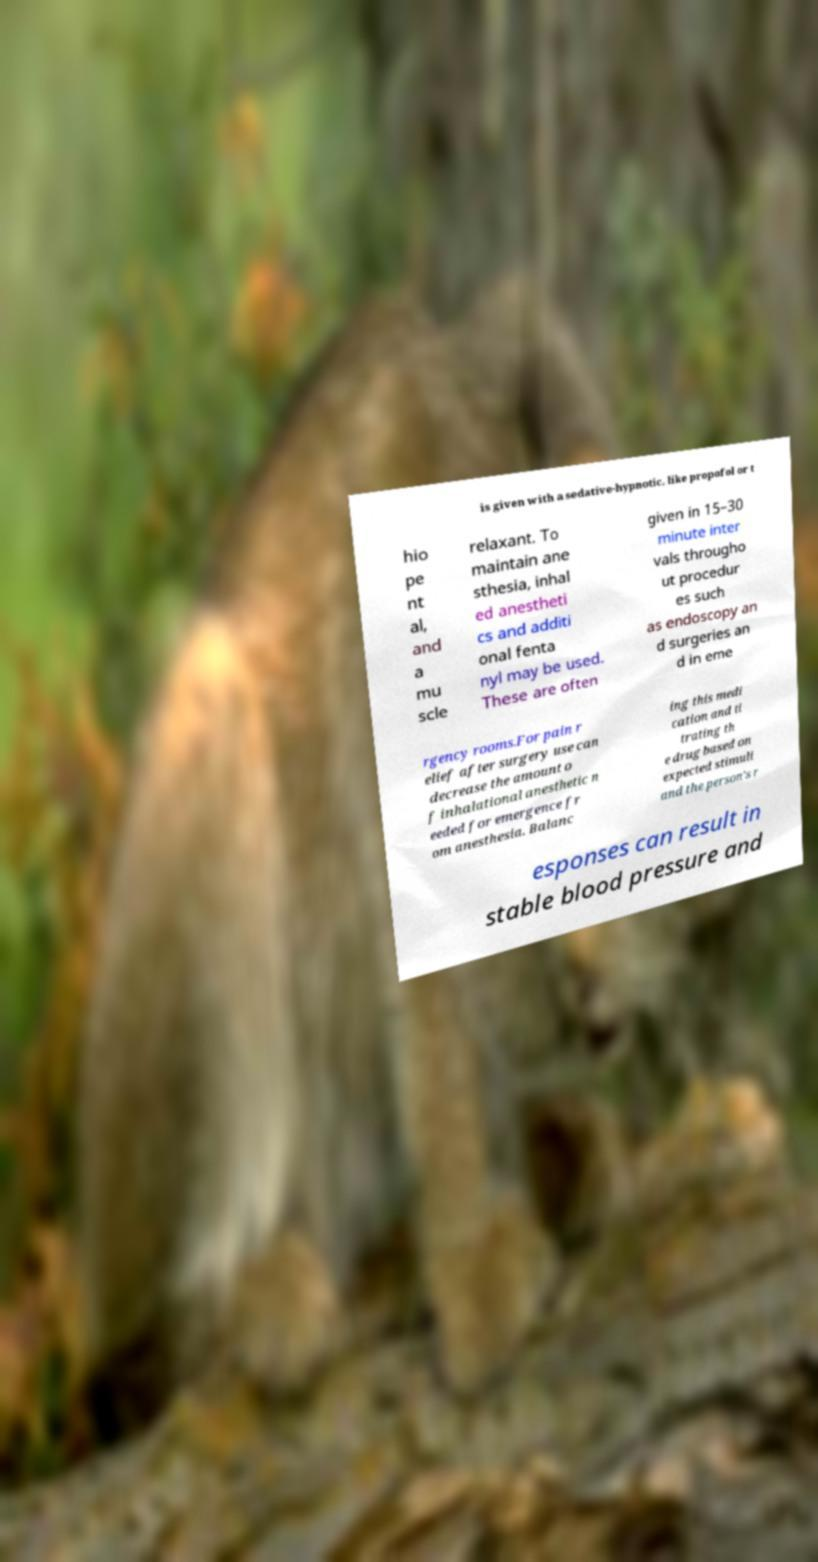Could you assist in decoding the text presented in this image and type it out clearly? is given with a sedative-hypnotic, like propofol or t hio pe nt al, and a mu scle relaxant. To maintain ane sthesia, inhal ed anestheti cs and additi onal fenta nyl may be used. These are often given in 15–30 minute inter vals througho ut procedur es such as endoscopy an d surgeries an d in eme rgency rooms.For pain r elief after surgery use can decrease the amount o f inhalational anesthetic n eeded for emergence fr om anesthesia. Balanc ing this medi cation and ti trating th e drug based on expected stimuli and the person's r esponses can result in stable blood pressure and 